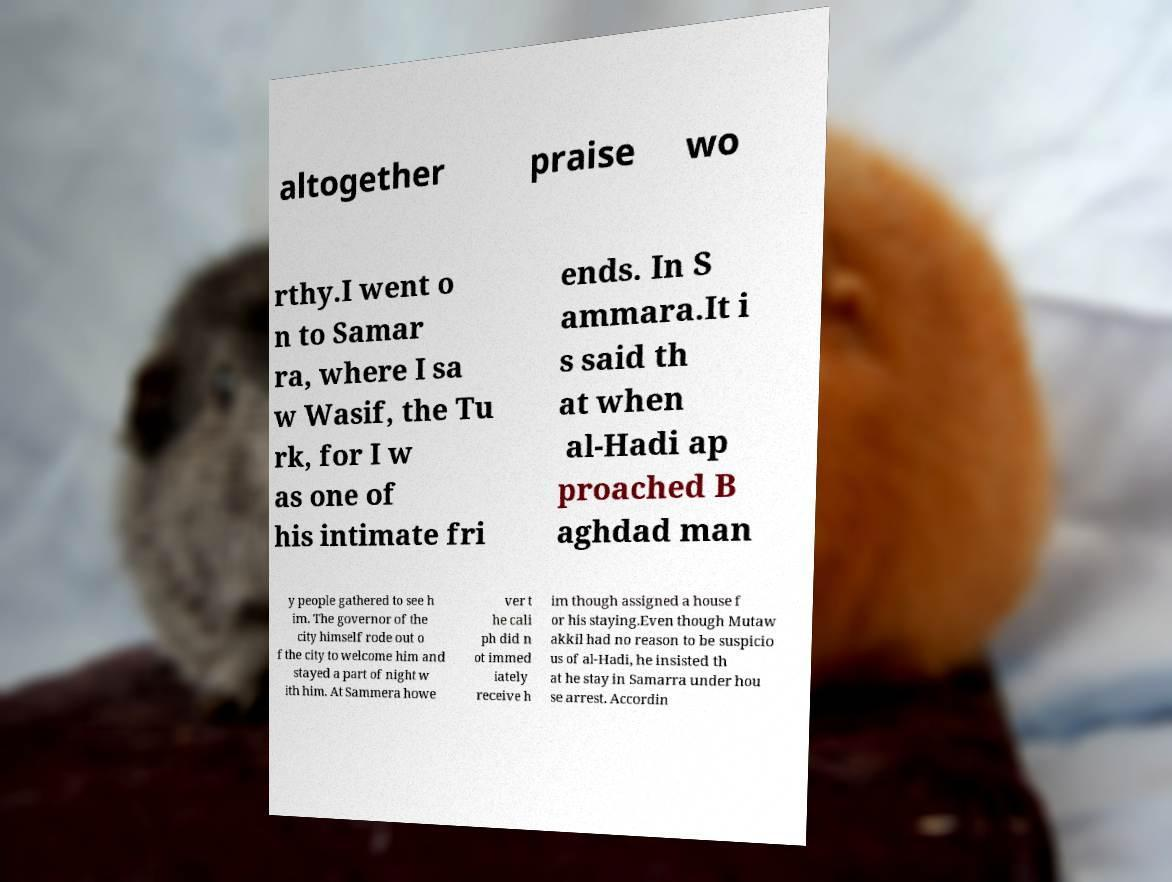Please identify and transcribe the text found in this image. altogether praise wo rthy.I went o n to Samar ra, where I sa w Wasif, the Tu rk, for I w as one of his intimate fri ends. In S ammara.It i s said th at when al-Hadi ap proached B aghdad man y people gathered to see h im. The governor of the city himself rode out o f the city to welcome him and stayed a part of night w ith him. At Sammera howe ver t he cali ph did n ot immed iately receive h im though assigned a house f or his staying.Even though Mutaw akkil had no reason to be suspicio us of al-Hadi, he insisted th at he stay in Samarra under hou se arrest. Accordin 